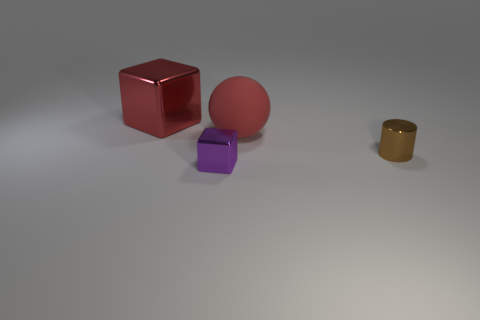Are there any other things that are made of the same material as the big red sphere?
Your answer should be very brief. No. Is the rubber thing the same size as the purple metal block?
Provide a succinct answer. No. Is the number of large red metal blocks that are to the right of the tiny brown cylinder the same as the number of purple metallic blocks that are to the right of the small purple shiny thing?
Your answer should be very brief. Yes. There is a shiny thing behind the rubber object; what is its shape?
Your answer should be compact. Cube. What is the shape of the other object that is the same size as the purple thing?
Offer a terse response. Cylinder. What is the color of the block to the right of the block behind the red thing that is to the right of the tiny purple shiny cube?
Provide a short and direct response. Purple. Is the shape of the big red rubber object the same as the purple thing?
Make the answer very short. No. Are there the same number of big red shiny things in front of the large red sphere and tiny cylinders?
Offer a very short reply. No. What number of other objects are there of the same material as the red sphere?
Offer a terse response. 0. Does the thing that is in front of the tiny brown metallic cylinder have the same size as the red object to the left of the red matte ball?
Keep it short and to the point. No. 